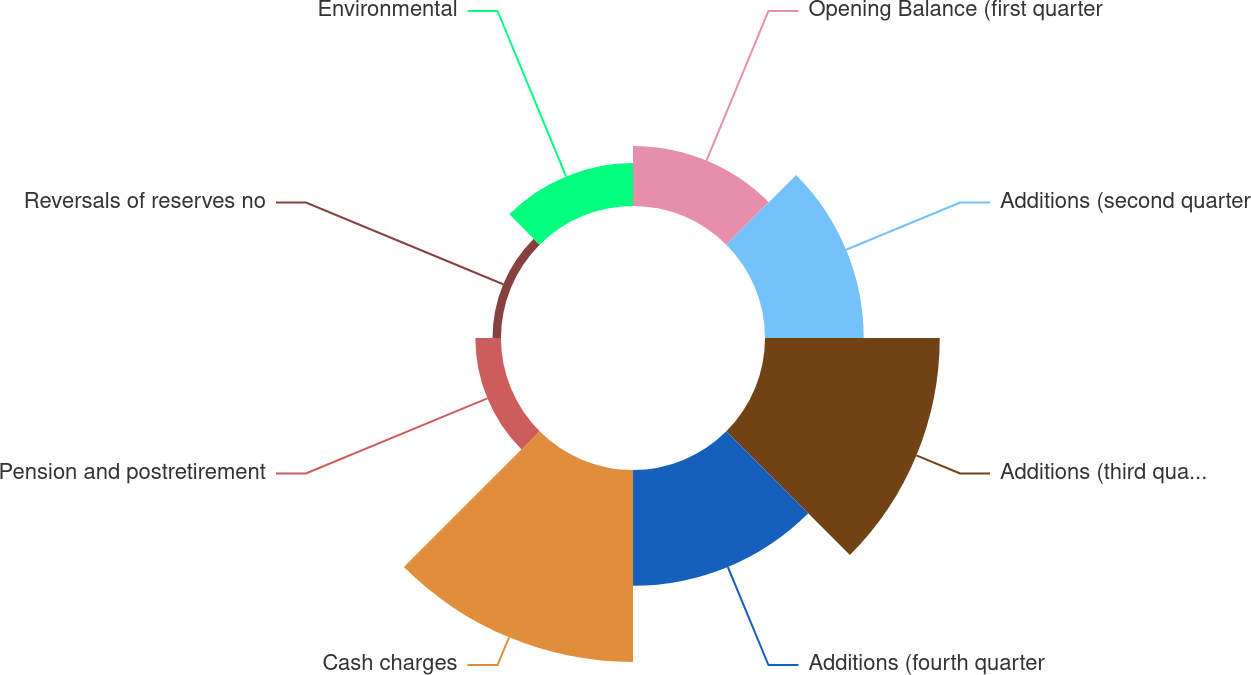<chart> <loc_0><loc_0><loc_500><loc_500><pie_chart><fcel>Opening Balance (first quarter<fcel>Additions (second quarter<fcel>Additions (third quarter 2003)<fcel>Additions (fourth quarter<fcel>Cash charges<fcel>Pension and postretirement<fcel>Reversals of reserves no<fcel>Environmental<nl><fcel>8.36%<fcel>13.74%<fcel>24.33%<fcel>16.13%<fcel>26.73%<fcel>3.57%<fcel>1.18%<fcel>5.97%<nl></chart> 